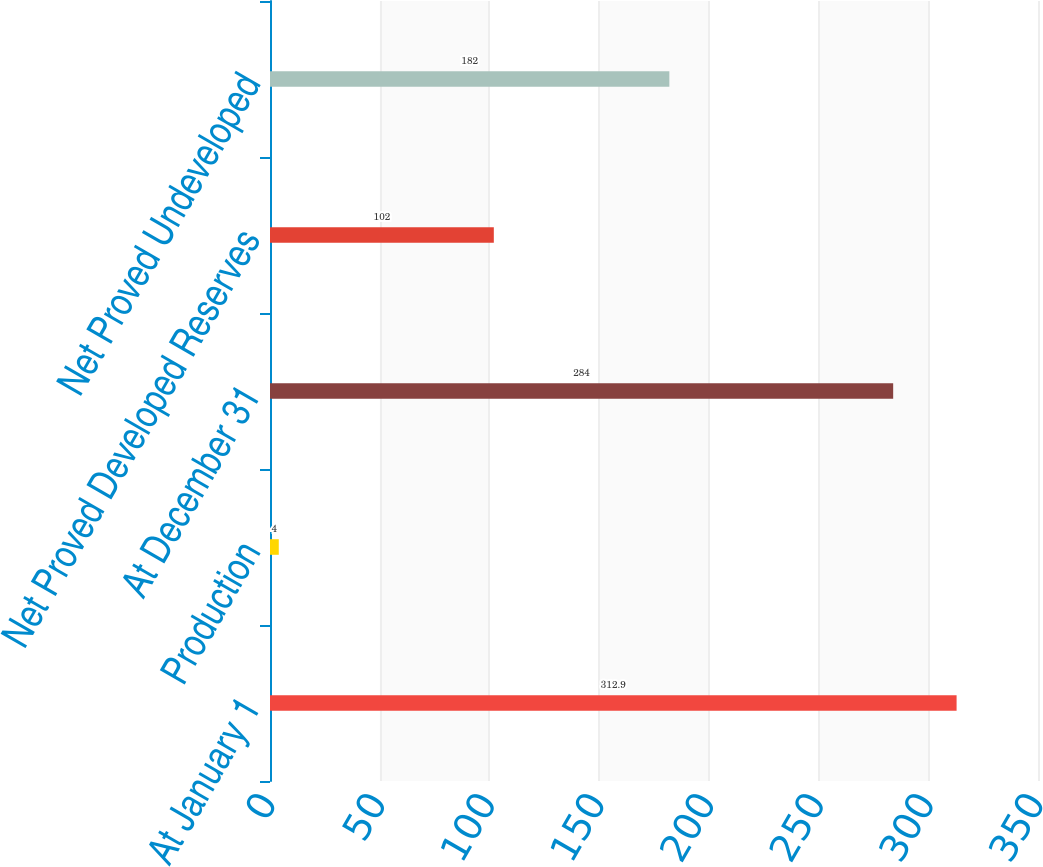Convert chart. <chart><loc_0><loc_0><loc_500><loc_500><bar_chart><fcel>At January 1<fcel>Production<fcel>At December 31<fcel>Net Proved Developed Reserves<fcel>Net Proved Undeveloped<nl><fcel>312.9<fcel>4<fcel>284<fcel>102<fcel>182<nl></chart> 